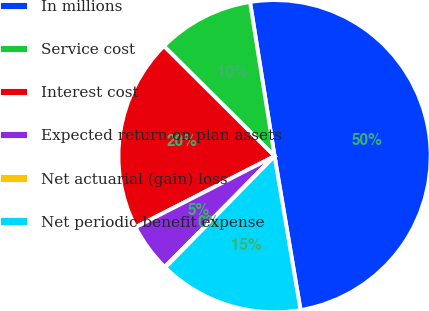<chart> <loc_0><loc_0><loc_500><loc_500><pie_chart><fcel>In millions<fcel>Service cost<fcel>Interest cost<fcel>Expected return on plan assets<fcel>Net actuarial (gain) loss<fcel>Net periodic benefit expense<nl><fcel>49.85%<fcel>10.03%<fcel>19.98%<fcel>5.05%<fcel>0.08%<fcel>15.01%<nl></chart> 